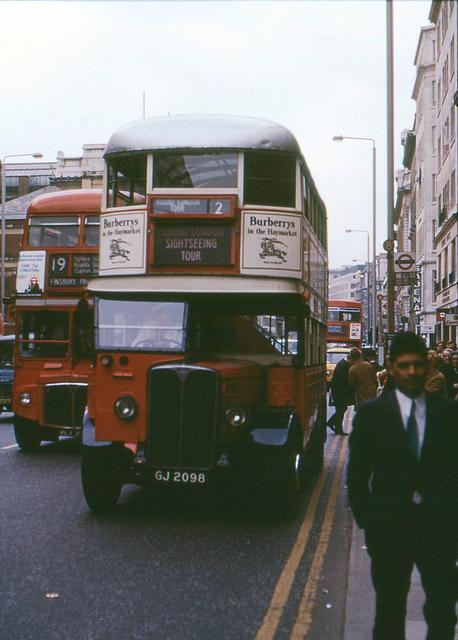How many double decker buses are in this scene?
Give a very brief answer. 3. How many buses are in the photo?
Give a very brief answer. 2. How many kites are in the sky?
Give a very brief answer. 0. 